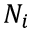Convert formula to latex. <formula><loc_0><loc_0><loc_500><loc_500>N _ { i }</formula> 